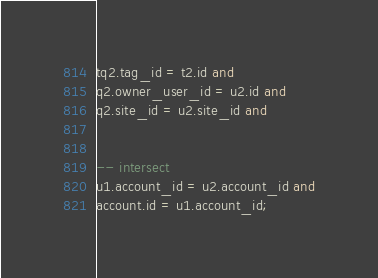Convert code to text. <code><loc_0><loc_0><loc_500><loc_500><_SQL_>tq2.tag_id = t2.id and
q2.owner_user_id = u2.id and
q2.site_id = u2.site_id and


-- intersect
u1.account_id = u2.account_id and
account.id = u1.account_id;

</code> 